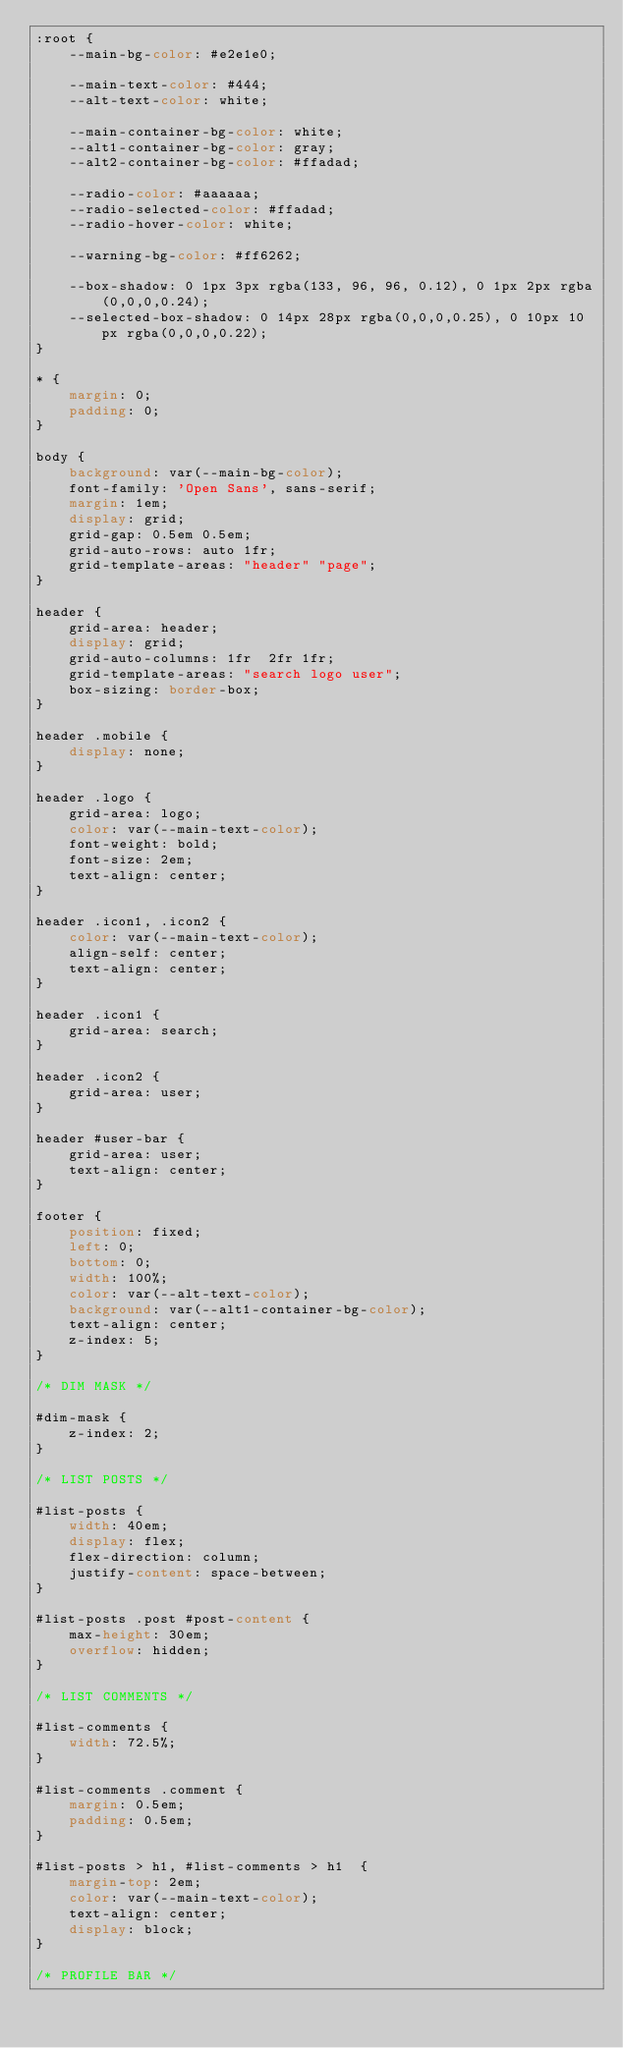<code> <loc_0><loc_0><loc_500><loc_500><_CSS_>:root {
	--main-bg-color: #e2e1e0;

	--main-text-color: #444;
	--alt-text-color: white;

	--main-container-bg-color: white;
	--alt1-container-bg-color: gray;
	--alt2-container-bg-color: #ffadad;

	--radio-color: #aaaaaa;
	--radio-selected-color: #ffadad;
	--radio-hover-color: white;

	--warning-bg-color: #ff6262;

	--box-shadow: 0 1px 3px rgba(133, 96, 96, 0.12), 0 1px 2px rgba(0,0,0,0.24);
	--selected-box-shadow: 0 14px 28px rgba(0,0,0,0.25), 0 10px 10px rgba(0,0,0,0.22);
}

* {
	margin: 0;
	padding: 0;
}

body {
	background: var(--main-bg-color);
	font-family: 'Open Sans', sans-serif;
	margin: 1em;
	display: grid;
	grid-gap: 0.5em 0.5em;
	grid-auto-rows: auto 1fr;
	grid-template-areas: "header" "page";
}

header {
	grid-area: header;
	display: grid;
	grid-auto-columns: 1fr  2fr 1fr;
	grid-template-areas: "search logo user";
	box-sizing: border-box;
}

header .mobile {
	display: none;
}

header .logo {
	grid-area: logo;
	color: var(--main-text-color);
	font-weight: bold;
	font-size: 2em;
	text-align: center;
} 

header .icon1, .icon2 {
	color: var(--main-text-color);
	align-self: center;
	text-align: center;
}

header .icon1 {
	grid-area: search;
} 

header .icon2 {
	grid-area: user;
}

header #user-bar {
	grid-area: user;
	text-align: center;
}

footer {
	position: fixed;
	left: 0;
	bottom: 0;
	width: 100%;
	color: var(--alt-text-color);
	background: var(--alt1-container-bg-color);
	text-align: center;
	z-index: 5;
}

/* DIM MASK */

#dim-mask {
	z-index: 2;
}

/* LIST POSTS */

#list-posts {
	width: 40em;
	display: flex;
	flex-direction: column;
	justify-content: space-between;
}

#list-posts .post #post-content {
	max-height: 30em;
	overflow: hidden;
}

/* LIST COMMENTS */

#list-comments {
	width: 72.5%;
}

#list-comments .comment {
	margin: 0.5em;
	padding: 0.5em;
}

#list-posts > h1, #list-comments > h1  {
	margin-top: 2em;
	color: var(--main-text-color);
	text-align: center;
	display: block;
}

/* PROFILE BAR */
</code> 